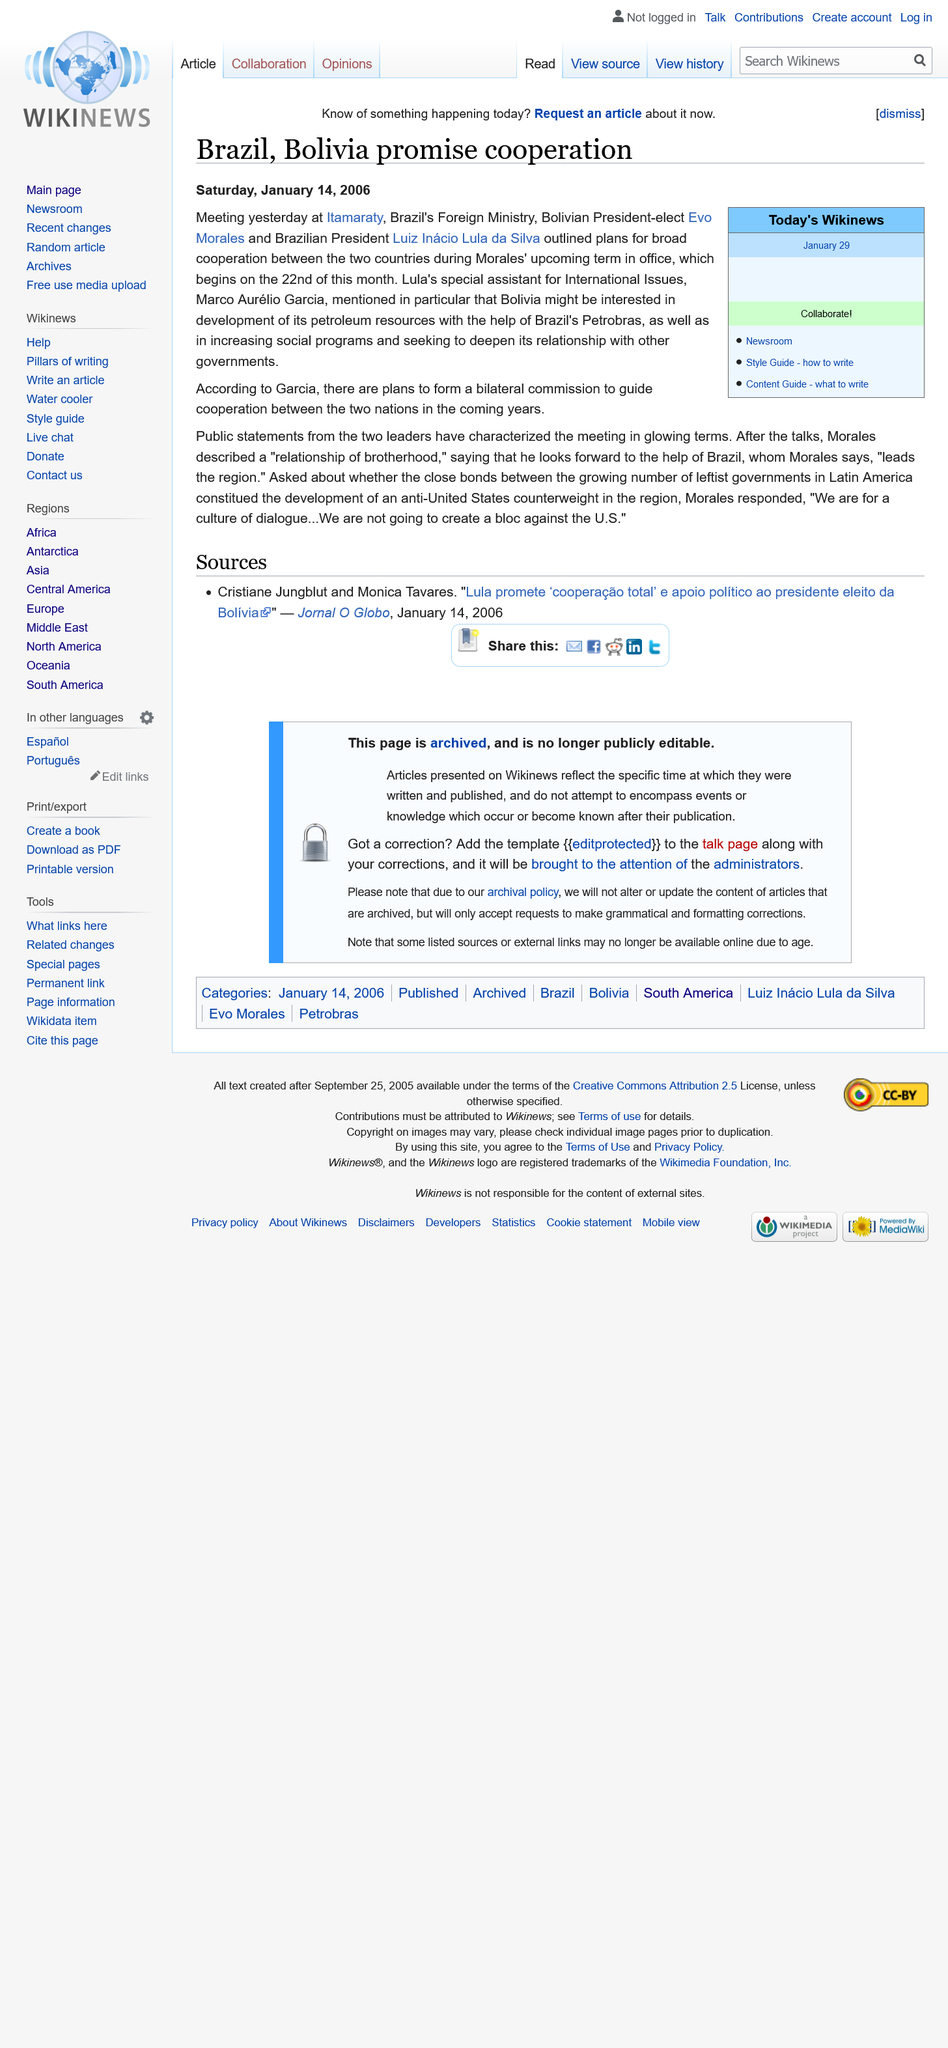Outline some significant characteristics in this image. The Brazilian President's special assistant for International Issues is Marco Aurelio Garcia. A meeting took place on January 13, 2006, Friday. The Bolivian President-elect is Evo Morales. 